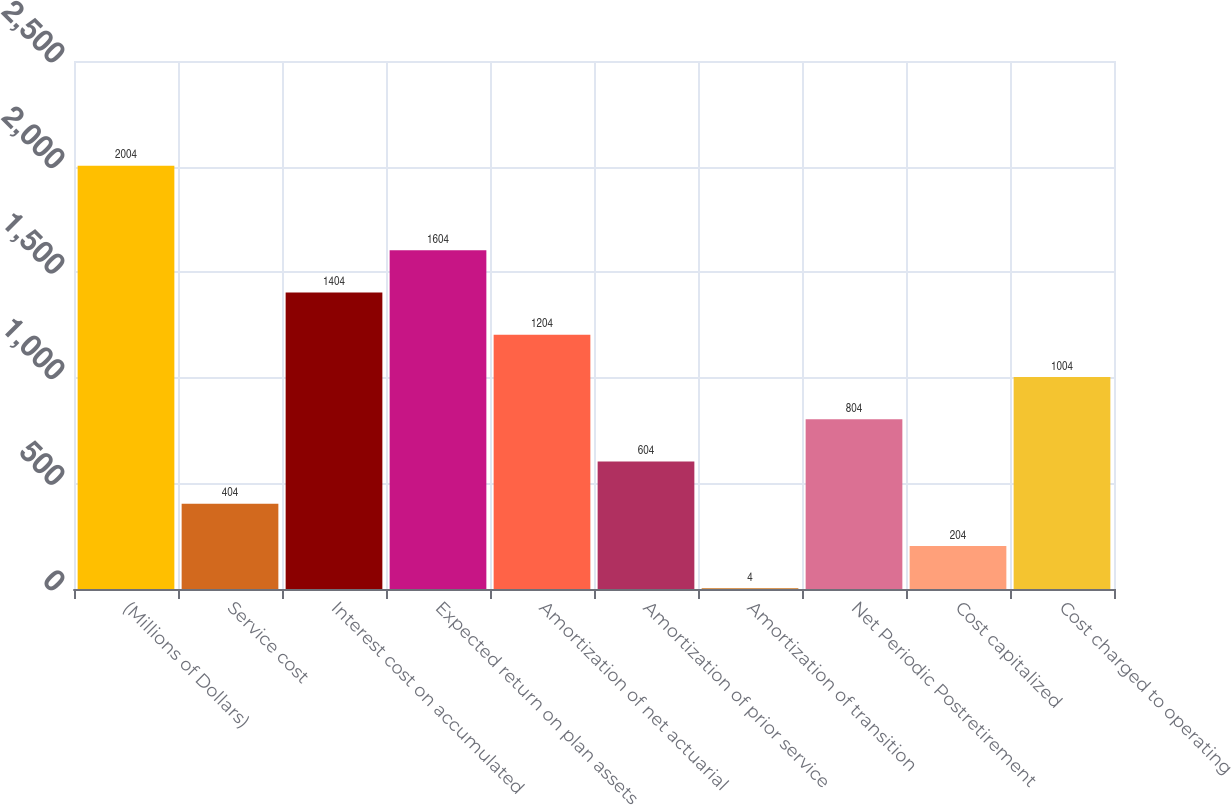Convert chart to OTSL. <chart><loc_0><loc_0><loc_500><loc_500><bar_chart><fcel>(Millions of Dollars)<fcel>Service cost<fcel>Interest cost on accumulated<fcel>Expected return on plan assets<fcel>Amortization of net actuarial<fcel>Amortization of prior service<fcel>Amortization of transition<fcel>Net Periodic Postretirement<fcel>Cost capitalized<fcel>Cost charged to operating<nl><fcel>2004<fcel>404<fcel>1404<fcel>1604<fcel>1204<fcel>604<fcel>4<fcel>804<fcel>204<fcel>1004<nl></chart> 